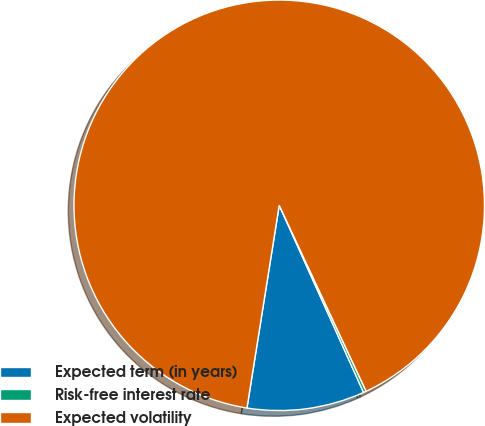<chart> <loc_0><loc_0><loc_500><loc_500><pie_chart><fcel>Expected term (in years)<fcel>Risk-free interest rate<fcel>Expected volatility<nl><fcel>9.25%<fcel>0.22%<fcel>90.54%<nl></chart> 